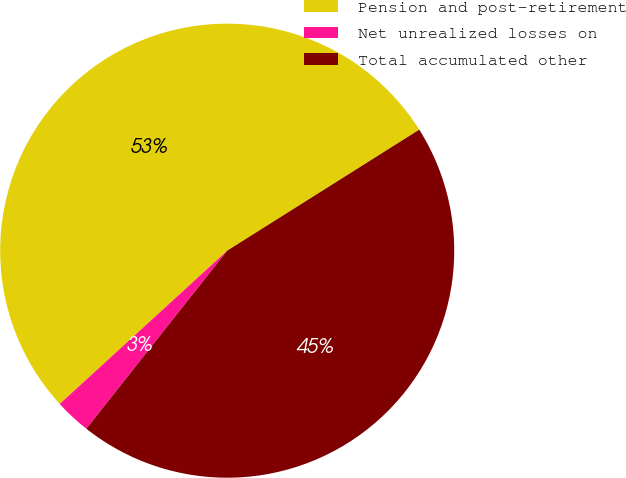Convert chart. <chart><loc_0><loc_0><loc_500><loc_500><pie_chart><fcel>Pension and post-retirement<fcel>Net unrealized losses on<fcel>Total accumulated other<nl><fcel>52.85%<fcel>2.55%<fcel>44.6%<nl></chart> 